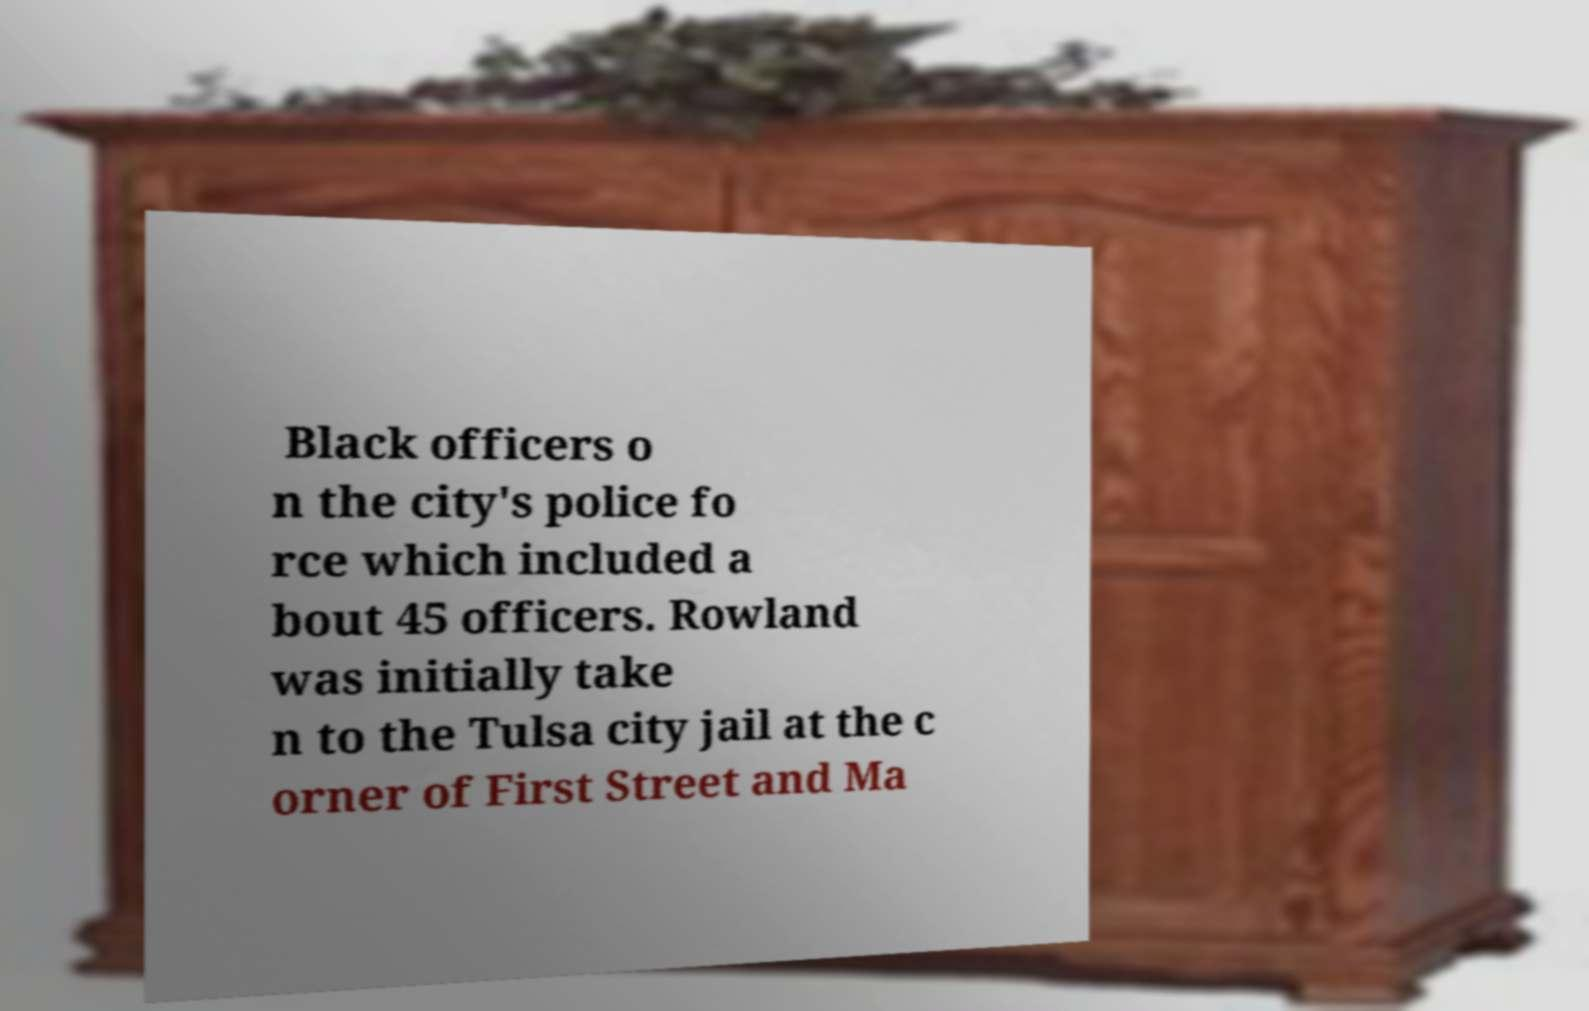Can you accurately transcribe the text from the provided image for me? Black officers o n the city's police fo rce which included a bout 45 officers. Rowland was initially take n to the Tulsa city jail at the c orner of First Street and Ma 